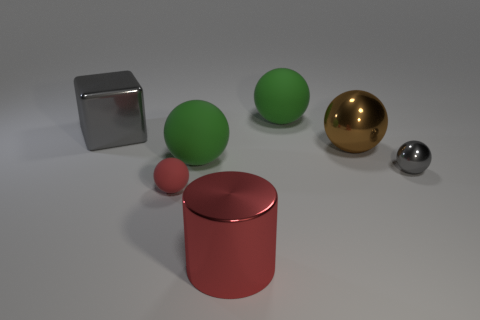Is the number of large objects greater than the number of things?
Offer a terse response. No. How many objects are objects that are in front of the big brown sphere or purple matte spheres?
Provide a short and direct response. 4. Are there any other purple cylinders that have the same size as the cylinder?
Provide a short and direct response. No. Is the number of large metallic objects less than the number of small cyan metallic balls?
Offer a very short reply. No. What number of balls are brown objects or tiny shiny things?
Your answer should be compact. 2. What number of large spheres are the same color as the big metallic cylinder?
Offer a very short reply. 0. There is a metallic object that is both to the left of the large brown metal object and behind the big red thing; what size is it?
Offer a very short reply. Large. Is the number of large cubes in front of the large cylinder less than the number of yellow matte cylinders?
Keep it short and to the point. No. Are the big red object and the brown thing made of the same material?
Provide a succinct answer. Yes. How many things are either tiny red shiny cubes or red cylinders?
Ensure brevity in your answer.  1. 